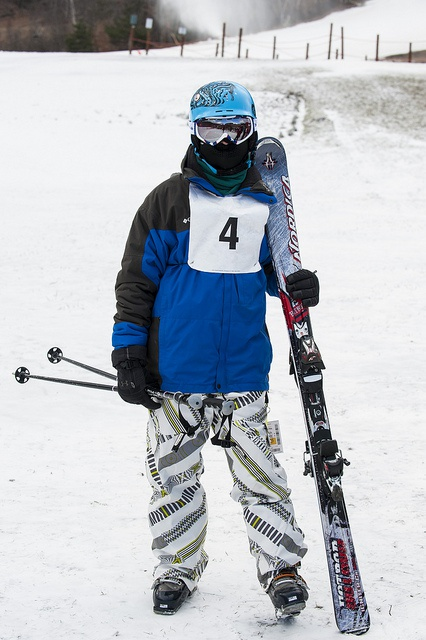Describe the objects in this image and their specific colors. I can see people in black, lightgray, blue, and navy tones and skis in black, lightgray, gray, and darkgray tones in this image. 